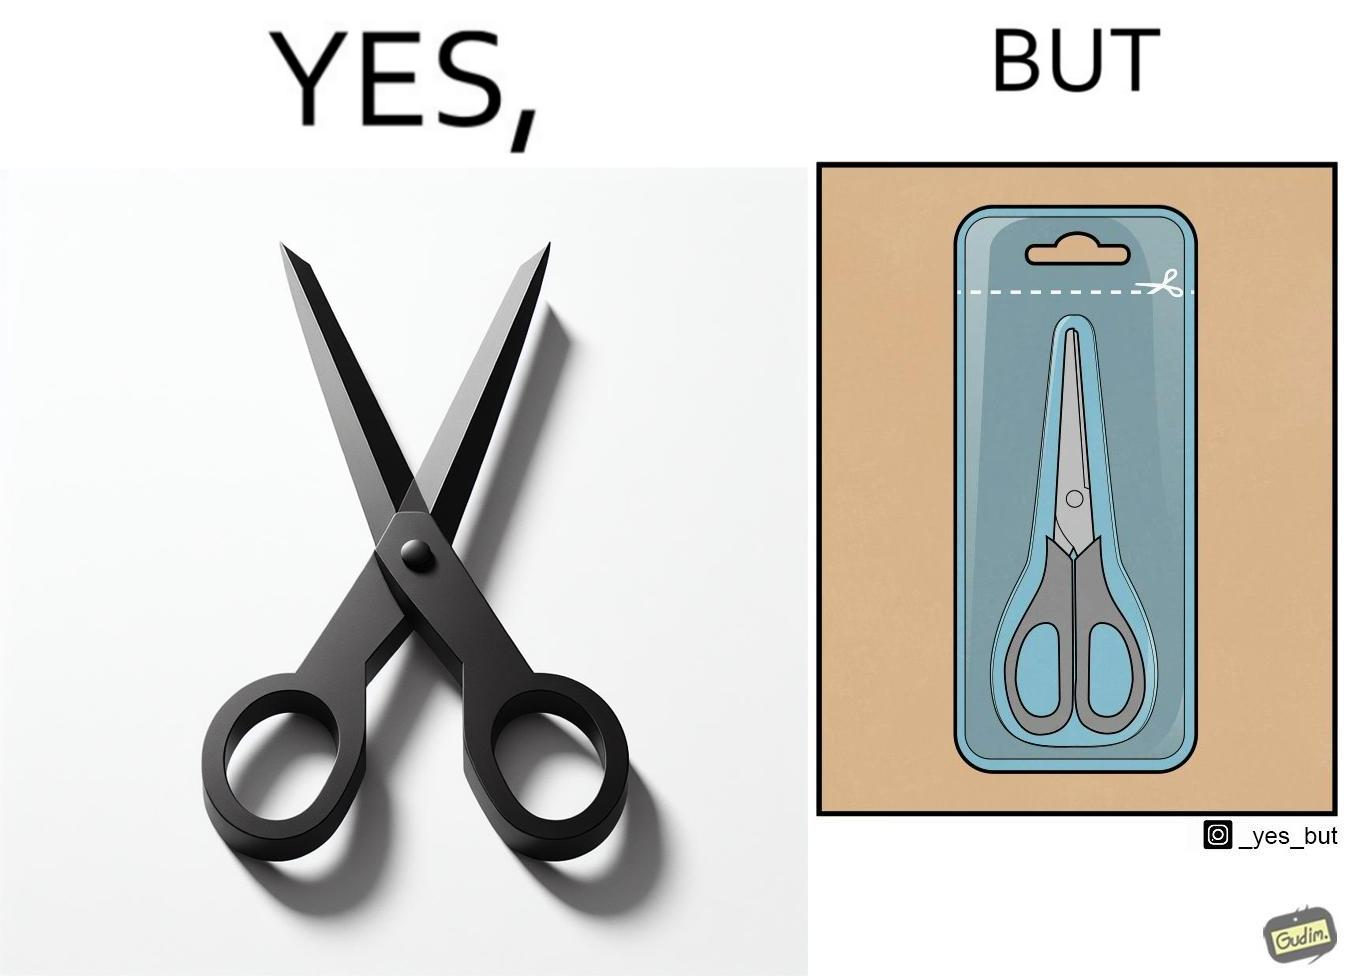Is this image satirical or non-satirical? Yes, this image is satirical. 